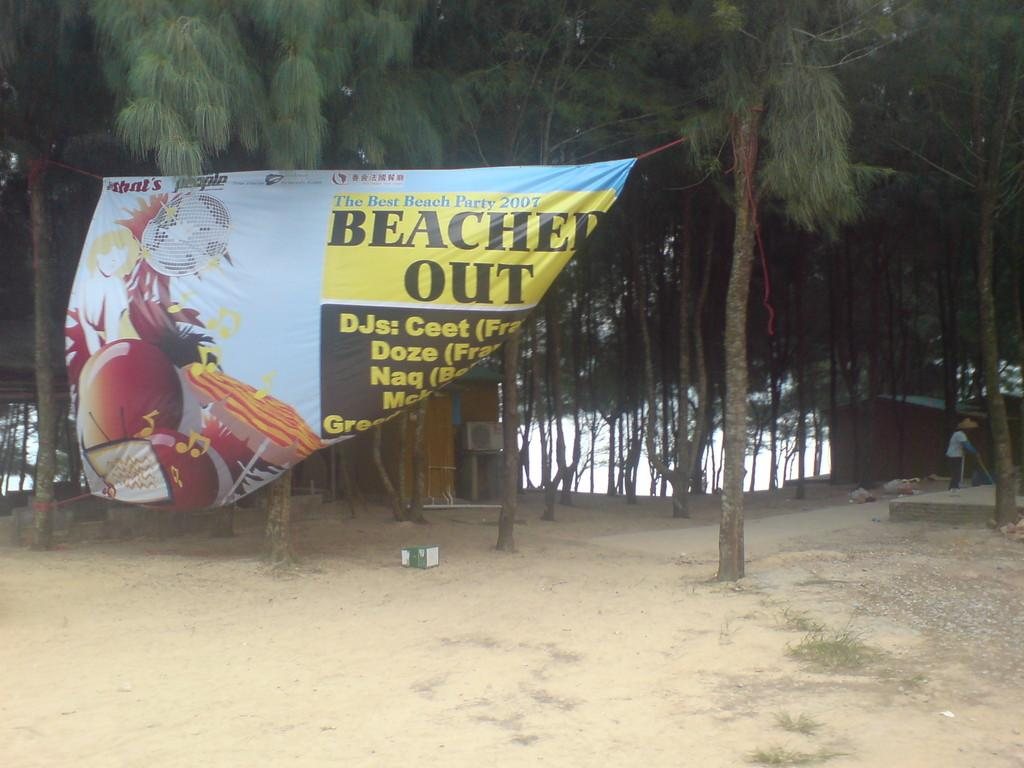What type of surface can be seen in the image? There is ground visible in the image. What is hanging or displayed in the image? There is a banner in the image. What object can be seen in the image that might contain other items? There is a box in the image. What type of structures are present in the image? There are sheds in the image. What type of vegetation is visible in the image? There are trees in the image. Where is the person standing in the image? There is a person standing on the ground on the right side of the image. What type of quill is the person holding in the image? There is no quill present in the image; the person is standing on the ground without holding any object. How many books can be seen in the image? There are no books visible in the image. 